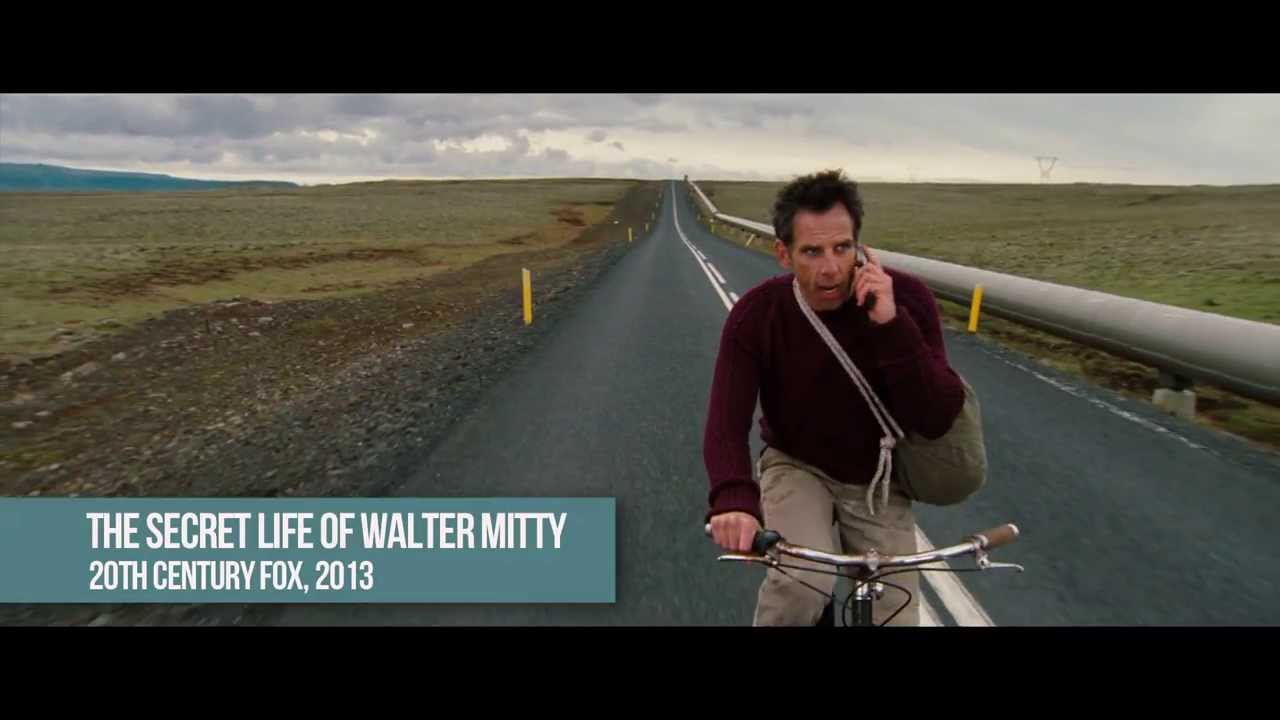Can you describe an alternate story for this scene, unrelated to the movie? In an alternate story, the man in the image is a scientist racing against time to deliver crucial research findings to a remote outpost. The barren landscape is a result of a climate experiment gone wrong, and the overcast skies are the result of artificial weather control. The bicycle is his only means of transport due to the failure of all modern vehicles in this harsh environment. His worried expression stems from the knowledge that the future of humanity depends on his success in delivering the information. Wow, that's interesting! What challenges might he face on his journey? On his journey, he might face a series of challenges including treacherous weather conditions, lack of food and water, and potential hostility from other desperate survivors scattered across the barren landscape. Mechanical failures with his bicycle, navigating through areas rendered unrecognizable by environmental changes, and psychological strains from isolation and the monumental responsibility of his mission could further complicate his path. If you could give him a tool or resource to help, what would it be? A solar-powered communication and navigation device would be an ideal tool for him. This device could help him stay in contact with his base, get real-time updates on environmental conditions, and find the safest and quickest route to his destination. Additionally, it would ensure that he remains connected even in the most remote and desolate parts of his journey. 